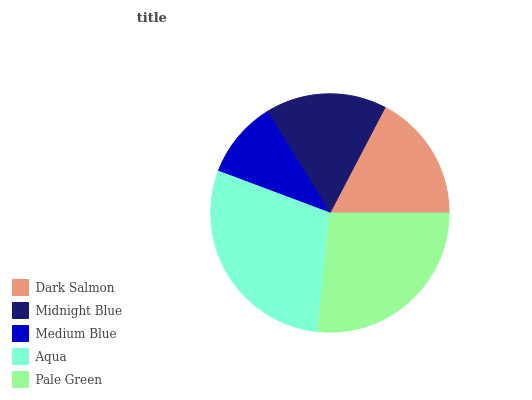Is Medium Blue the minimum?
Answer yes or no. Yes. Is Aqua the maximum?
Answer yes or no. Yes. Is Midnight Blue the minimum?
Answer yes or no. No. Is Midnight Blue the maximum?
Answer yes or no. No. Is Dark Salmon greater than Midnight Blue?
Answer yes or no. Yes. Is Midnight Blue less than Dark Salmon?
Answer yes or no. Yes. Is Midnight Blue greater than Dark Salmon?
Answer yes or no. No. Is Dark Salmon less than Midnight Blue?
Answer yes or no. No. Is Dark Salmon the high median?
Answer yes or no. Yes. Is Dark Salmon the low median?
Answer yes or no. Yes. Is Pale Green the high median?
Answer yes or no. No. Is Midnight Blue the low median?
Answer yes or no. No. 